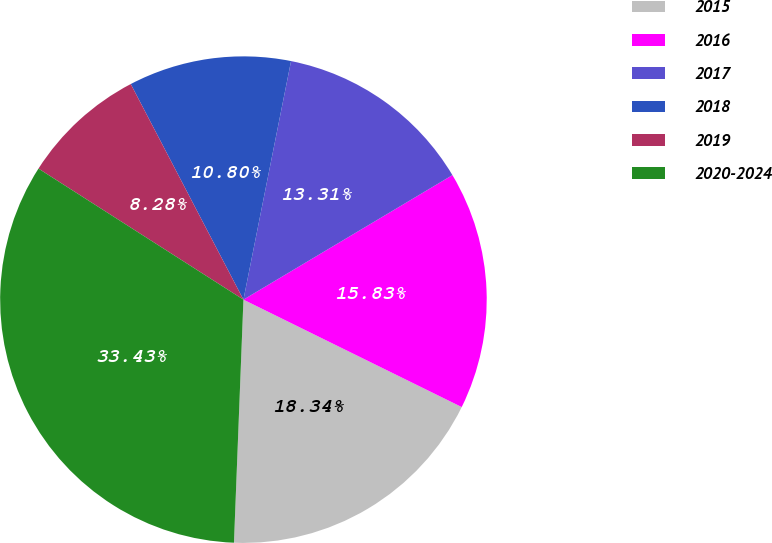<chart> <loc_0><loc_0><loc_500><loc_500><pie_chart><fcel>2015<fcel>2016<fcel>2017<fcel>2018<fcel>2019<fcel>2020-2024<nl><fcel>18.34%<fcel>15.83%<fcel>13.31%<fcel>10.8%<fcel>8.28%<fcel>33.43%<nl></chart> 